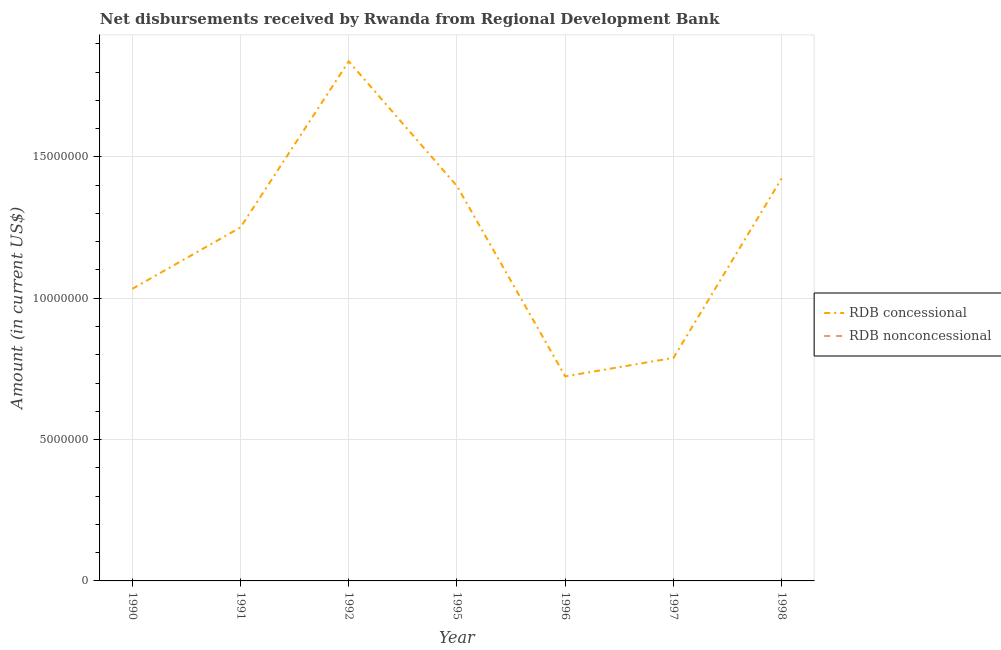Is the number of lines equal to the number of legend labels?
Offer a terse response. No. What is the net concessional disbursements from rdb in 1997?
Your response must be concise. 7.89e+06. Across all years, what is the maximum net concessional disbursements from rdb?
Make the answer very short. 1.84e+07. What is the difference between the net concessional disbursements from rdb in 1996 and that in 1997?
Provide a short and direct response. -6.53e+05. What is the difference between the net non concessional disbursements from rdb in 1998 and the net concessional disbursements from rdb in 1992?
Offer a very short reply. -1.84e+07. What is the average net concessional disbursements from rdb per year?
Make the answer very short. 1.21e+07. In how many years, is the net concessional disbursements from rdb greater than 4000000 US$?
Your answer should be compact. 7. What is the ratio of the net concessional disbursements from rdb in 1990 to that in 1997?
Give a very brief answer. 1.31. Is the net concessional disbursements from rdb in 1991 less than that in 1997?
Your answer should be compact. No. What is the difference between the highest and the second highest net concessional disbursements from rdb?
Provide a succinct answer. 4.14e+06. What is the difference between the highest and the lowest net concessional disbursements from rdb?
Give a very brief answer. 1.11e+07. Does the net concessional disbursements from rdb monotonically increase over the years?
Your answer should be compact. No. Is the net non concessional disbursements from rdb strictly less than the net concessional disbursements from rdb over the years?
Keep it short and to the point. Yes. How many lines are there?
Make the answer very short. 1. Are the values on the major ticks of Y-axis written in scientific E-notation?
Your answer should be very brief. No. Does the graph contain grids?
Your answer should be compact. Yes. Where does the legend appear in the graph?
Provide a succinct answer. Center right. How are the legend labels stacked?
Keep it short and to the point. Vertical. What is the title of the graph?
Your answer should be compact. Net disbursements received by Rwanda from Regional Development Bank. Does "Import" appear as one of the legend labels in the graph?
Provide a short and direct response. No. What is the label or title of the X-axis?
Your response must be concise. Year. What is the Amount (in current US$) of RDB concessional in 1990?
Ensure brevity in your answer.  1.03e+07. What is the Amount (in current US$) of RDB nonconcessional in 1990?
Provide a succinct answer. 0. What is the Amount (in current US$) of RDB concessional in 1991?
Ensure brevity in your answer.  1.25e+07. What is the Amount (in current US$) in RDB concessional in 1992?
Provide a succinct answer. 1.84e+07. What is the Amount (in current US$) in RDB concessional in 1995?
Your answer should be compact. 1.40e+07. What is the Amount (in current US$) in RDB nonconcessional in 1995?
Ensure brevity in your answer.  0. What is the Amount (in current US$) in RDB concessional in 1996?
Offer a very short reply. 7.24e+06. What is the Amount (in current US$) in RDB nonconcessional in 1996?
Make the answer very short. 0. What is the Amount (in current US$) in RDB concessional in 1997?
Ensure brevity in your answer.  7.89e+06. What is the Amount (in current US$) of RDB nonconcessional in 1997?
Make the answer very short. 0. What is the Amount (in current US$) in RDB concessional in 1998?
Give a very brief answer. 1.42e+07. Across all years, what is the maximum Amount (in current US$) of RDB concessional?
Offer a terse response. 1.84e+07. Across all years, what is the minimum Amount (in current US$) of RDB concessional?
Offer a terse response. 7.24e+06. What is the total Amount (in current US$) in RDB concessional in the graph?
Ensure brevity in your answer.  8.46e+07. What is the total Amount (in current US$) in RDB nonconcessional in the graph?
Provide a short and direct response. 0. What is the difference between the Amount (in current US$) of RDB concessional in 1990 and that in 1991?
Your answer should be very brief. -2.18e+06. What is the difference between the Amount (in current US$) in RDB concessional in 1990 and that in 1992?
Offer a terse response. -8.05e+06. What is the difference between the Amount (in current US$) of RDB concessional in 1990 and that in 1995?
Your answer should be compact. -3.64e+06. What is the difference between the Amount (in current US$) of RDB concessional in 1990 and that in 1996?
Ensure brevity in your answer.  3.10e+06. What is the difference between the Amount (in current US$) in RDB concessional in 1990 and that in 1997?
Give a very brief answer. 2.44e+06. What is the difference between the Amount (in current US$) of RDB concessional in 1990 and that in 1998?
Offer a terse response. -3.91e+06. What is the difference between the Amount (in current US$) in RDB concessional in 1991 and that in 1992?
Offer a very short reply. -5.87e+06. What is the difference between the Amount (in current US$) of RDB concessional in 1991 and that in 1995?
Offer a terse response. -1.46e+06. What is the difference between the Amount (in current US$) in RDB concessional in 1991 and that in 1996?
Offer a very short reply. 5.27e+06. What is the difference between the Amount (in current US$) of RDB concessional in 1991 and that in 1997?
Your answer should be compact. 4.62e+06. What is the difference between the Amount (in current US$) in RDB concessional in 1991 and that in 1998?
Make the answer very short. -1.73e+06. What is the difference between the Amount (in current US$) of RDB concessional in 1992 and that in 1995?
Keep it short and to the point. 4.41e+06. What is the difference between the Amount (in current US$) of RDB concessional in 1992 and that in 1996?
Provide a succinct answer. 1.11e+07. What is the difference between the Amount (in current US$) in RDB concessional in 1992 and that in 1997?
Your answer should be compact. 1.05e+07. What is the difference between the Amount (in current US$) of RDB concessional in 1992 and that in 1998?
Offer a terse response. 4.14e+06. What is the difference between the Amount (in current US$) of RDB concessional in 1995 and that in 1996?
Your response must be concise. 6.73e+06. What is the difference between the Amount (in current US$) of RDB concessional in 1995 and that in 1997?
Your response must be concise. 6.08e+06. What is the difference between the Amount (in current US$) of RDB concessional in 1996 and that in 1997?
Ensure brevity in your answer.  -6.53e+05. What is the difference between the Amount (in current US$) in RDB concessional in 1996 and that in 1998?
Your response must be concise. -7.00e+06. What is the difference between the Amount (in current US$) in RDB concessional in 1997 and that in 1998?
Provide a succinct answer. -6.35e+06. What is the average Amount (in current US$) in RDB concessional per year?
Provide a succinct answer. 1.21e+07. What is the ratio of the Amount (in current US$) of RDB concessional in 1990 to that in 1991?
Make the answer very short. 0.83. What is the ratio of the Amount (in current US$) of RDB concessional in 1990 to that in 1992?
Provide a succinct answer. 0.56. What is the ratio of the Amount (in current US$) of RDB concessional in 1990 to that in 1995?
Provide a short and direct response. 0.74. What is the ratio of the Amount (in current US$) in RDB concessional in 1990 to that in 1996?
Offer a terse response. 1.43. What is the ratio of the Amount (in current US$) in RDB concessional in 1990 to that in 1997?
Your response must be concise. 1.31. What is the ratio of the Amount (in current US$) in RDB concessional in 1990 to that in 1998?
Provide a short and direct response. 0.73. What is the ratio of the Amount (in current US$) in RDB concessional in 1991 to that in 1992?
Make the answer very short. 0.68. What is the ratio of the Amount (in current US$) in RDB concessional in 1991 to that in 1995?
Make the answer very short. 0.9. What is the ratio of the Amount (in current US$) of RDB concessional in 1991 to that in 1996?
Give a very brief answer. 1.73. What is the ratio of the Amount (in current US$) of RDB concessional in 1991 to that in 1997?
Offer a very short reply. 1.59. What is the ratio of the Amount (in current US$) in RDB concessional in 1991 to that in 1998?
Your answer should be compact. 0.88. What is the ratio of the Amount (in current US$) of RDB concessional in 1992 to that in 1995?
Your answer should be very brief. 1.32. What is the ratio of the Amount (in current US$) of RDB concessional in 1992 to that in 1996?
Offer a terse response. 2.54. What is the ratio of the Amount (in current US$) of RDB concessional in 1992 to that in 1997?
Offer a very short reply. 2.33. What is the ratio of the Amount (in current US$) in RDB concessional in 1992 to that in 1998?
Keep it short and to the point. 1.29. What is the ratio of the Amount (in current US$) in RDB concessional in 1995 to that in 1996?
Offer a very short reply. 1.93. What is the ratio of the Amount (in current US$) in RDB concessional in 1995 to that in 1997?
Offer a very short reply. 1.77. What is the ratio of the Amount (in current US$) in RDB concessional in 1996 to that in 1997?
Your response must be concise. 0.92. What is the ratio of the Amount (in current US$) of RDB concessional in 1996 to that in 1998?
Provide a short and direct response. 0.51. What is the ratio of the Amount (in current US$) of RDB concessional in 1997 to that in 1998?
Keep it short and to the point. 0.55. What is the difference between the highest and the second highest Amount (in current US$) in RDB concessional?
Your answer should be compact. 4.14e+06. What is the difference between the highest and the lowest Amount (in current US$) in RDB concessional?
Offer a terse response. 1.11e+07. 